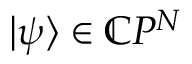<formula> <loc_0><loc_0><loc_500><loc_500>| \psi \rangle \in \mathbb { C } P ^ { N }</formula> 